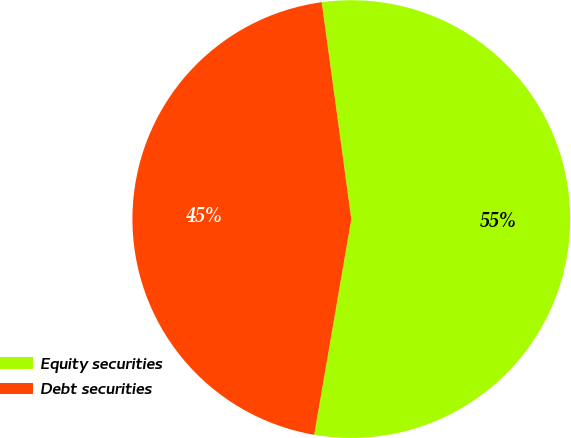<chart> <loc_0><loc_0><loc_500><loc_500><pie_chart><fcel>Equity securities<fcel>Debt securities<nl><fcel>54.87%<fcel>45.13%<nl></chart> 